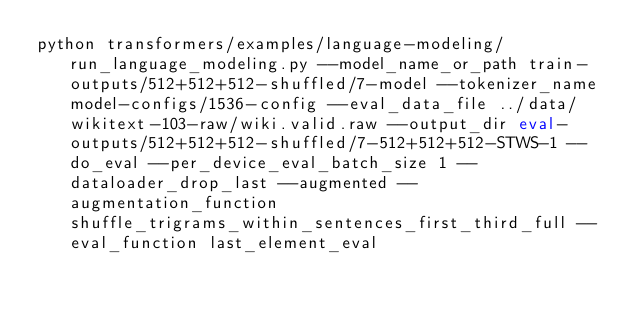Convert code to text. <code><loc_0><loc_0><loc_500><loc_500><_Bash_>python transformers/examples/language-modeling/run_language_modeling.py --model_name_or_path train-outputs/512+512+512-shuffled/7-model --tokenizer_name model-configs/1536-config --eval_data_file ../data/wikitext-103-raw/wiki.valid.raw --output_dir eval-outputs/512+512+512-shuffled/7-512+512+512-STWS-1 --do_eval --per_device_eval_batch_size 1 --dataloader_drop_last --augmented --augmentation_function shuffle_trigrams_within_sentences_first_third_full --eval_function last_element_eval</code> 